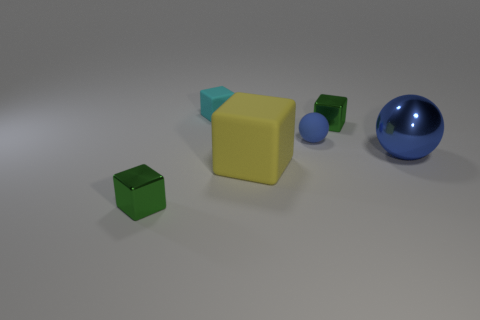There is a object that is to the left of the cyan thing; is its size the same as the green metallic cube behind the big metal ball?
Give a very brief answer. Yes. What is the shape of the tiny metal thing that is right of the tiny thing on the left side of the small cyan block?
Keep it short and to the point. Cube. Is the size of the matte ball the same as the matte thing in front of the big metal sphere?
Your answer should be very brief. No. There is a yellow block that is in front of the green cube behind the metal thing in front of the big metal ball; how big is it?
Give a very brief answer. Large. What number of objects are either tiny metallic blocks left of the rubber sphere or tiny blue balls?
Keep it short and to the point. 2. There is a tiny green metal thing that is right of the large matte cube; how many large yellow objects are on the right side of it?
Offer a terse response. 0. Is the number of big shiny spheres that are on the right side of the large shiny ball greater than the number of small matte blocks?
Your answer should be very brief. No. There is a thing that is both behind the big sphere and on the left side of the big yellow rubber thing; how big is it?
Provide a short and direct response. Small. There is a thing that is on the left side of the matte ball and right of the small cyan matte cube; what shape is it?
Offer a terse response. Cube. There is a small metallic object that is behind the tiny green metallic thing that is left of the cyan rubber cube; is there a cyan matte block that is on the right side of it?
Your answer should be compact. No. 